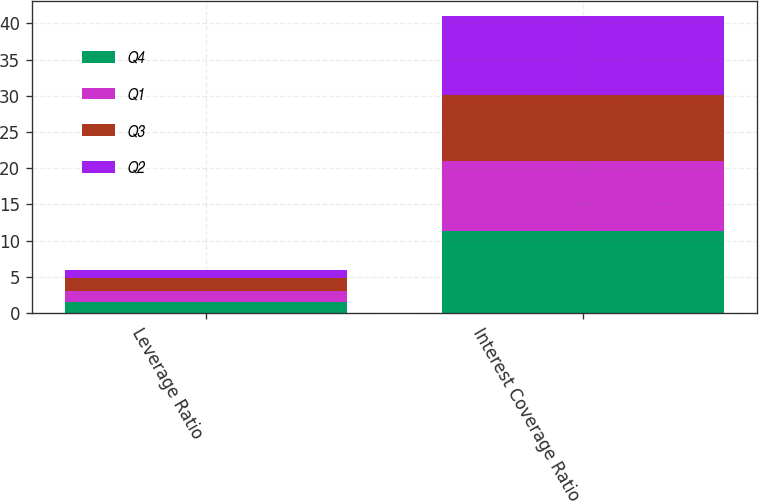<chart> <loc_0><loc_0><loc_500><loc_500><stacked_bar_chart><ecel><fcel>Leverage Ratio<fcel>Interest Coverage Ratio<nl><fcel>Q4<fcel>1.48<fcel>11.31<nl><fcel>Q1<fcel>1.63<fcel>9.64<nl><fcel>Q3<fcel>1.77<fcel>9.12<nl><fcel>Q2<fcel>1.11<fcel>11.01<nl></chart> 